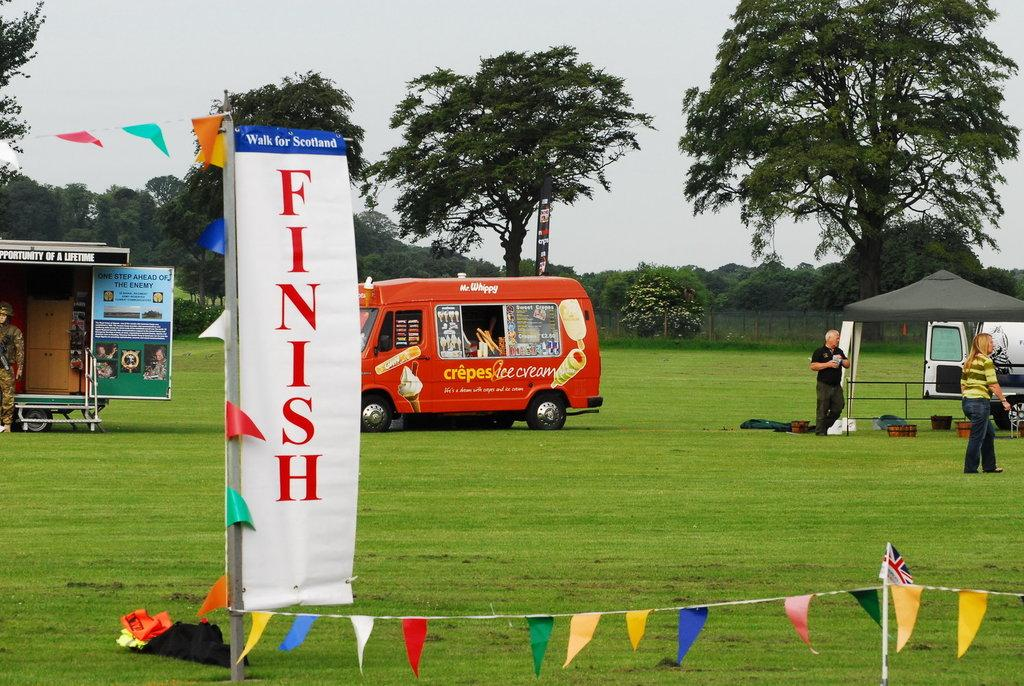What is the primary vegetation covering the land in the image? The land is covered with grass. What are the two types of fabric displays in the image? There are flags and banners in the image. What structure can be seen in the background of the image? There is a tent in the background of the image. What can be seen in the distance behind the tent? There are vehicles, people, and trees in the background of the image. What objects are placed directly on the grass? There are buckets on the grass. Can you describe any other objects on the grass? There are other objects on the grass, but their specific nature is not mentioned in the facts. How many sisters are present in the image? There is no mention of a sister or any family members in the image. What is the rate of increase in the number of houses in the image? There are no houses present in the image, so it is not possible to determine any rate of increase. 